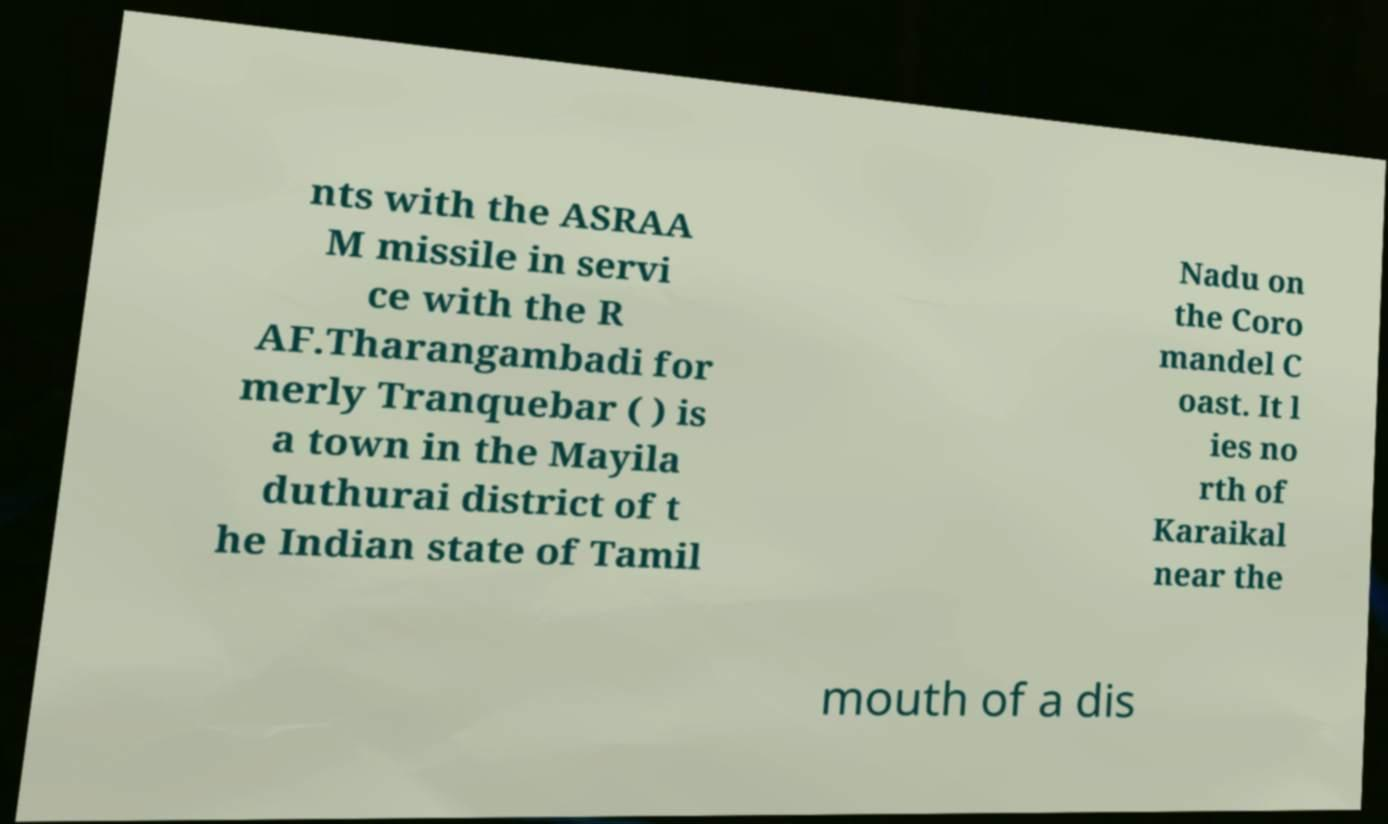For documentation purposes, I need the text within this image transcribed. Could you provide that? nts with the ASRAA M missile in servi ce with the R AF.Tharangambadi for merly Tranquebar ( ) is a town in the Mayila duthurai district of t he Indian state of Tamil Nadu on the Coro mandel C oast. It l ies no rth of Karaikal near the mouth of a dis 